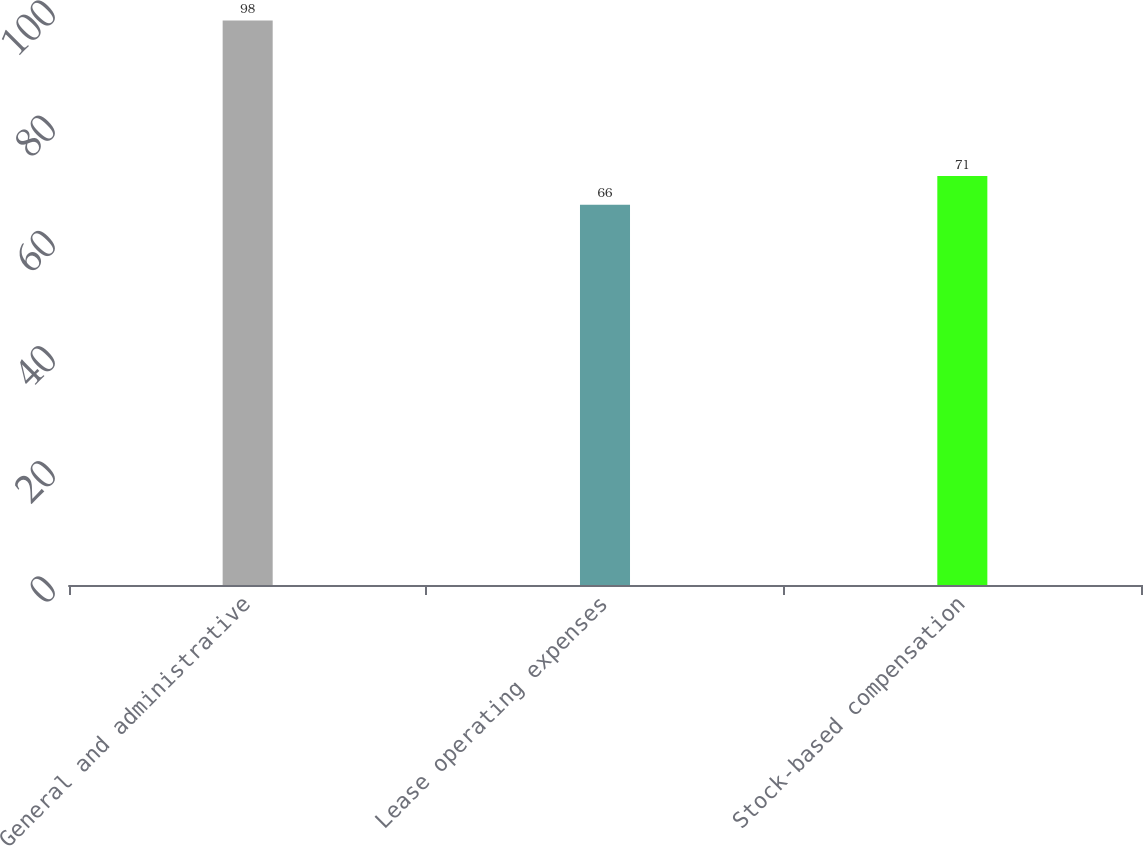<chart> <loc_0><loc_0><loc_500><loc_500><bar_chart><fcel>General and administrative<fcel>Lease operating expenses<fcel>Stock-based compensation<nl><fcel>98<fcel>66<fcel>71<nl></chart> 